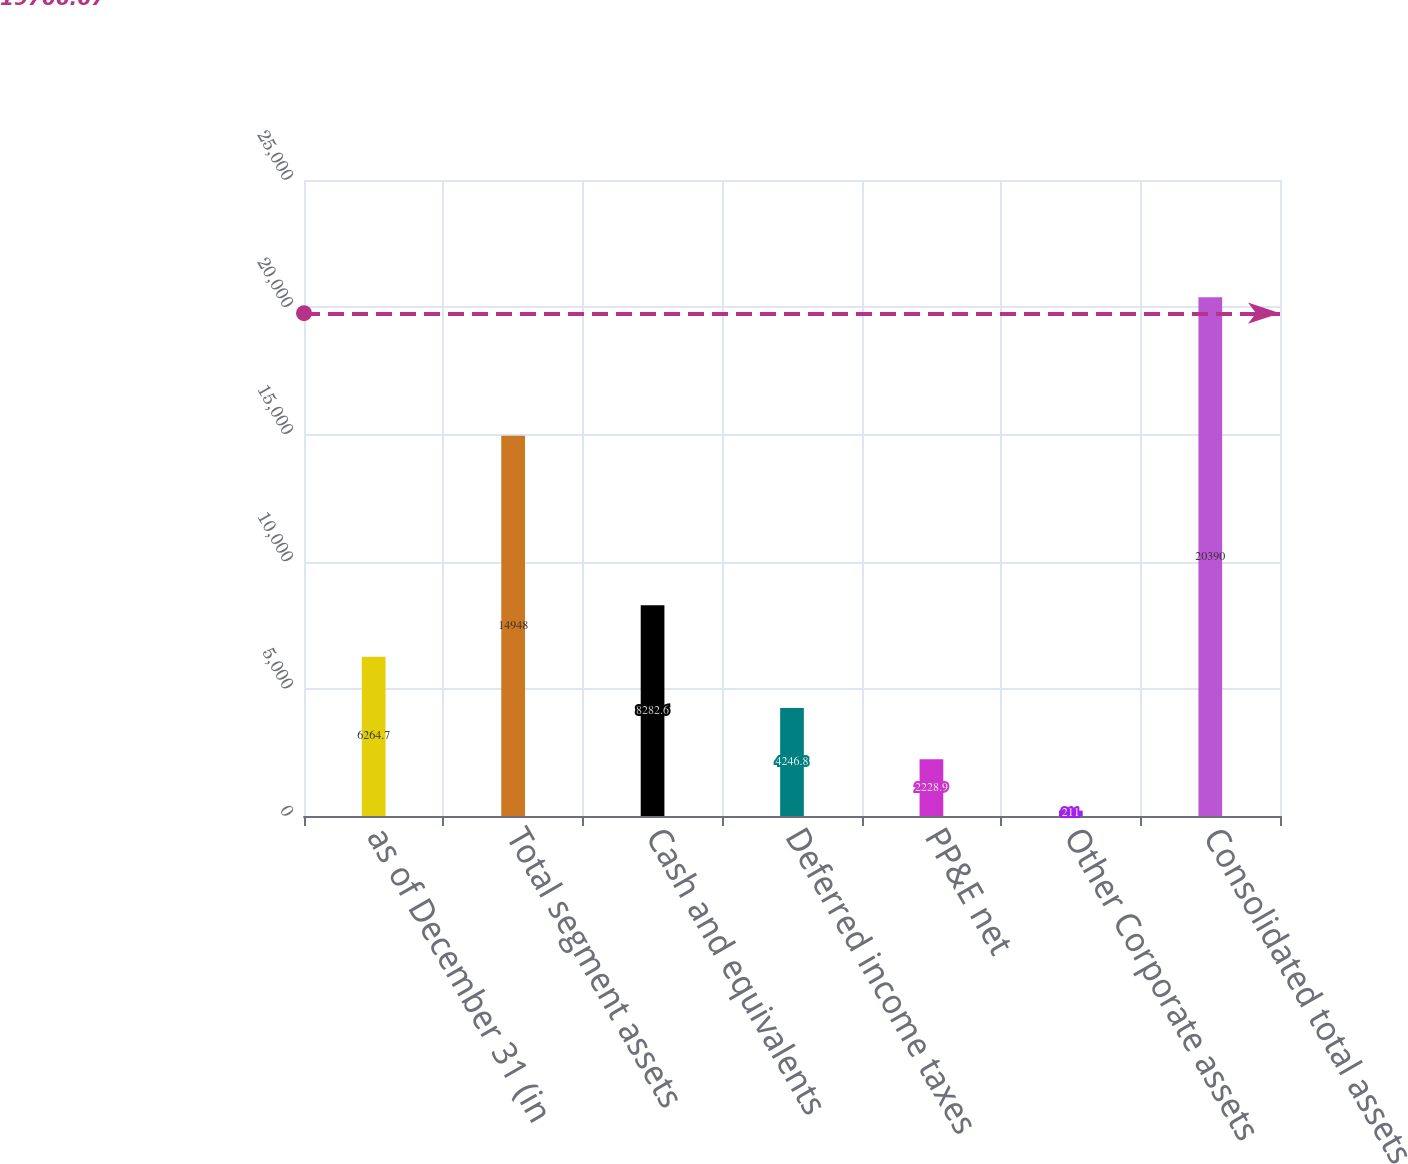Convert chart to OTSL. <chart><loc_0><loc_0><loc_500><loc_500><bar_chart><fcel>as of December 31 (in<fcel>Total segment assets<fcel>Cash and equivalents<fcel>Deferred income taxes<fcel>PP&E net<fcel>Other Corporate assets<fcel>Consolidated total assets<nl><fcel>6264.7<fcel>14948<fcel>8282.6<fcel>4246.8<fcel>2228.9<fcel>211<fcel>20390<nl></chart> 